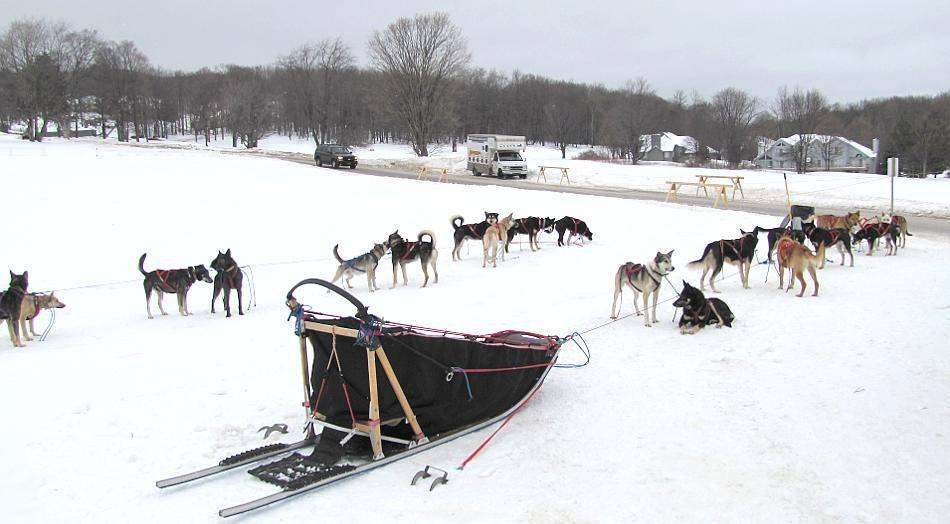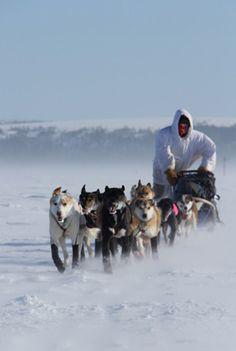The first image is the image on the left, the second image is the image on the right. Evaluate the accuracy of this statement regarding the images: "At least one image shows a sled dog team headed straight, away from the camera.". Is it true? Answer yes or no. No. The first image is the image on the left, the second image is the image on the right. Given the left and right images, does the statement "The sled on the snow in one of the images is empty." hold true? Answer yes or no. Yes. 